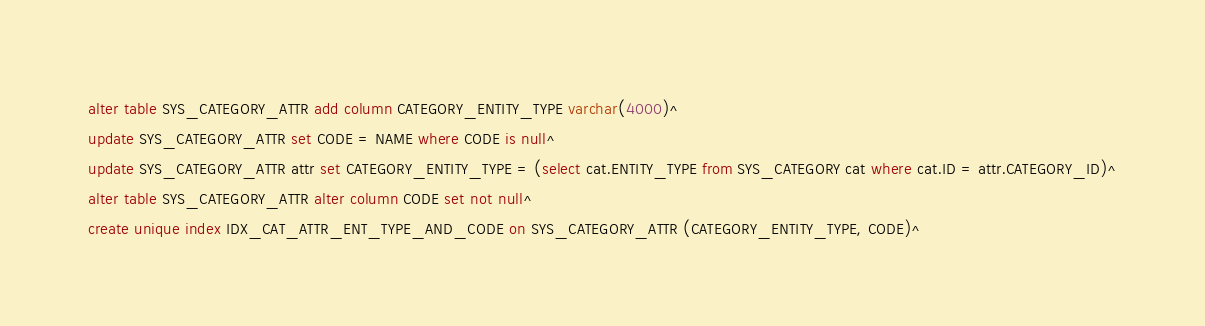Convert code to text. <code><loc_0><loc_0><loc_500><loc_500><_SQL_>alter table SYS_CATEGORY_ATTR add column CATEGORY_ENTITY_TYPE varchar(4000)^
update SYS_CATEGORY_ATTR set CODE = NAME where CODE is null^
update SYS_CATEGORY_ATTR attr set CATEGORY_ENTITY_TYPE = (select cat.ENTITY_TYPE from SYS_CATEGORY cat where cat.ID = attr.CATEGORY_ID)^
alter table SYS_CATEGORY_ATTR alter column CODE set not null^
create unique index IDX_CAT_ATTR_ENT_TYPE_AND_CODE on SYS_CATEGORY_ATTR (CATEGORY_ENTITY_TYPE, CODE)^
</code> 